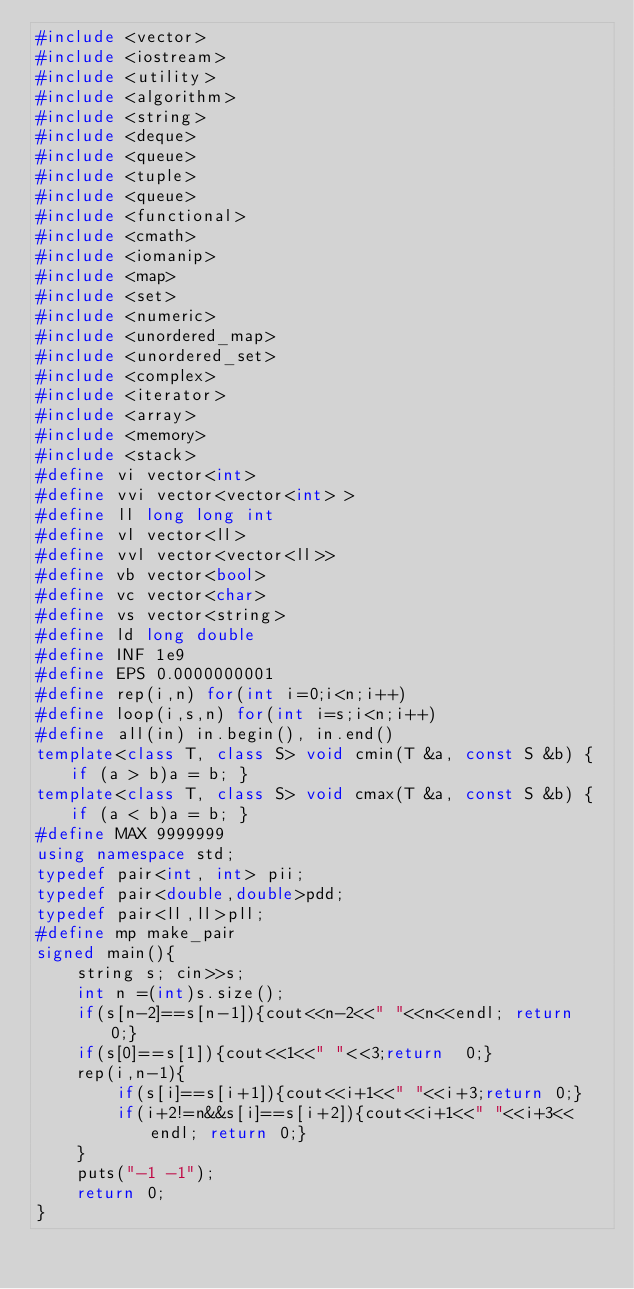Convert code to text. <code><loc_0><loc_0><loc_500><loc_500><_C++_>#include <vector>
#include <iostream>
#include <utility>
#include <algorithm>
#include <string>
#include <deque>
#include <queue>
#include <tuple>
#include <queue>
#include <functional>
#include <cmath>
#include <iomanip>
#include <map>
#include <set>
#include <numeric>
#include <unordered_map>
#include <unordered_set>
#include <complex>
#include <iterator>
#include <array>
#include <memory>
#include <stack>
#define vi vector<int>
#define vvi vector<vector<int> >
#define ll long long int
#define vl vector<ll>
#define vvl vector<vector<ll>>
#define vb vector<bool>
#define vc vector<char>
#define vs vector<string>
#define ld long double
#define INF 1e9
#define EPS 0.0000000001
#define rep(i,n) for(int i=0;i<n;i++)
#define loop(i,s,n) for(int i=s;i<n;i++)
#define all(in) in.begin(), in.end()
template<class T, class S> void cmin(T &a, const S &b) { if (a > b)a = b; }
template<class T, class S> void cmax(T &a, const S &b) { if (a < b)a = b; }
#define MAX 9999999
using namespace std;
typedef pair<int, int> pii;
typedef pair<double,double>pdd;
typedef pair<ll,ll>pll;
#define mp make_pair
signed main(){
    string s; cin>>s;
    int n =(int)s.size();
    if(s[n-2]==s[n-1]){cout<<n-2<<" "<<n<<endl; return 0;}
    if(s[0]==s[1]){cout<<1<<" "<<3;return  0;}
    rep(i,n-1){
        if(s[i]==s[i+1]){cout<<i+1<<" "<<i+3;return 0;}
        if(i+2!=n&&s[i]==s[i+2]){cout<<i+1<<" "<<i+3<<endl; return 0;}
    }
    puts("-1 -1");
    return 0;
}
</code> 